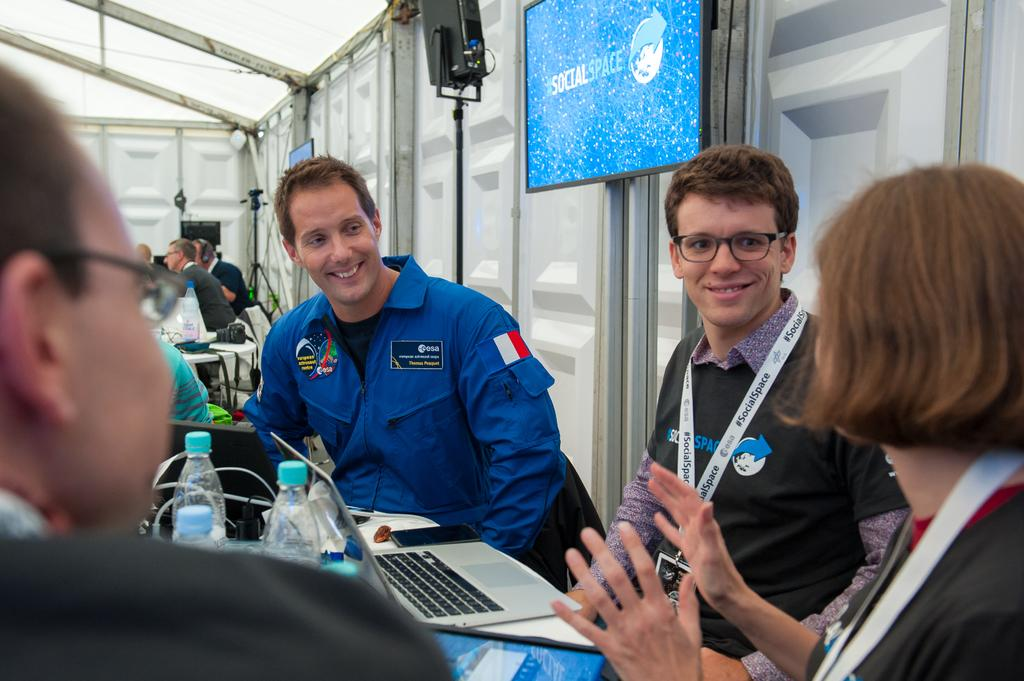What is the general expression of the people in the image? The people in the image have smiles. How are the people positioned in the image? The people are sitting on chairs. What objects can be seen on the table in the image? There are electronic devices on a table. What can be seen on the screen in the image? There is a screen visible in the image. What type of pipe is being smoked by the people in the image? There is no pipe present in the image; the people have smiles and are sitting on chairs. What is the weather like in the image? The provided facts do not mention the weather, so it cannot be determined from the image. 